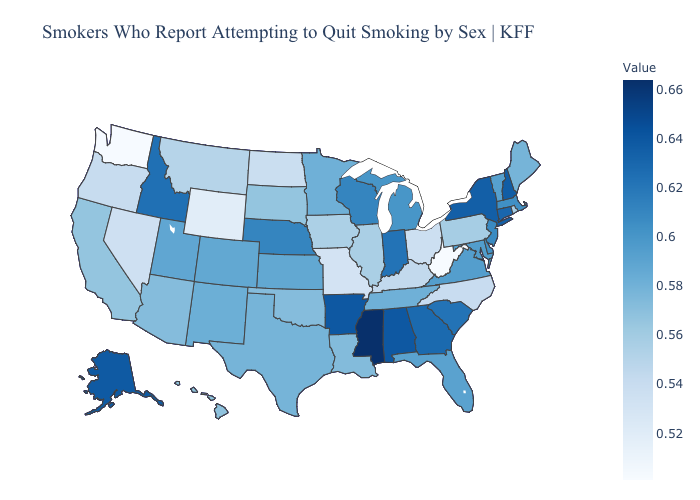Which states hav the highest value in the West?
Give a very brief answer. Alaska. Does Pennsylvania have the highest value in the Northeast?
Answer briefly. No. Does Montana have the lowest value in the USA?
Concise answer only. No. Which states hav the highest value in the MidWest?
Write a very short answer. Indiana. Among the states that border Delaware , which have the highest value?
Short answer required. New Jersey. Which states have the lowest value in the USA?
Answer briefly. West Virginia. Does Michigan have the lowest value in the USA?
Keep it brief. No. Does Arizona have a higher value than Maryland?
Answer briefly. No. Does Arkansas have a lower value than Mississippi?
Answer briefly. Yes. 